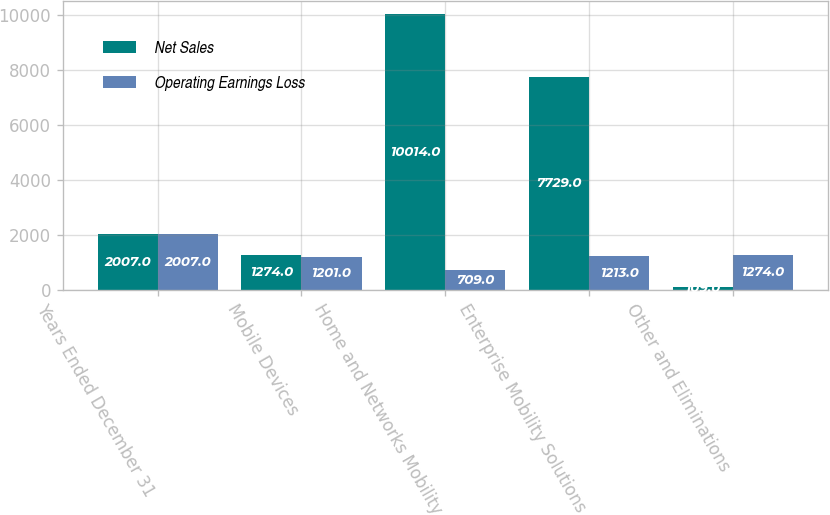Convert chart to OTSL. <chart><loc_0><loc_0><loc_500><loc_500><stacked_bar_chart><ecel><fcel>Years Ended December 31<fcel>Mobile Devices<fcel>Home and Networks Mobility<fcel>Enterprise Mobility Solutions<fcel>Other and Eliminations<nl><fcel>Net Sales<fcel>2007<fcel>1274<fcel>10014<fcel>7729<fcel>109<nl><fcel>Operating Earnings Loss<fcel>2007<fcel>1201<fcel>709<fcel>1213<fcel>1274<nl></chart> 